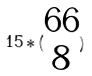<formula> <loc_0><loc_0><loc_500><loc_500>1 5 * ( \begin{matrix} 6 6 \\ 8 \end{matrix} )</formula> 